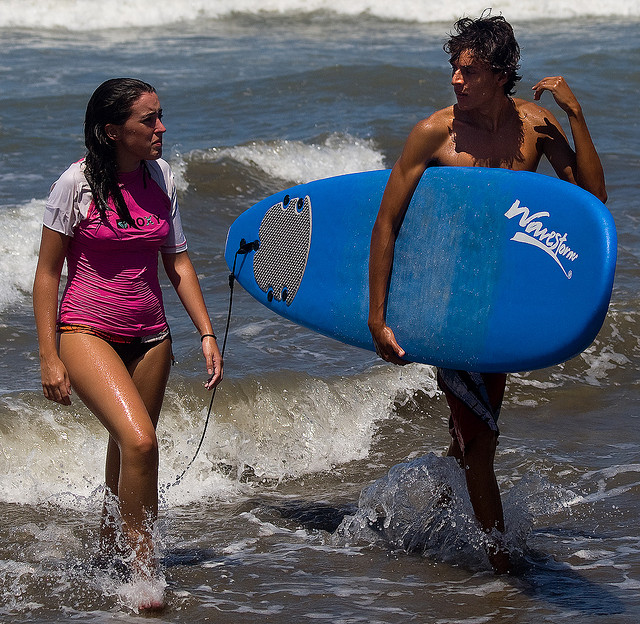<image>Is the woman happy? I don't know if the woman is happy. Is the woman happy? I don't know if the woman is happy. It can be either yes or no. 